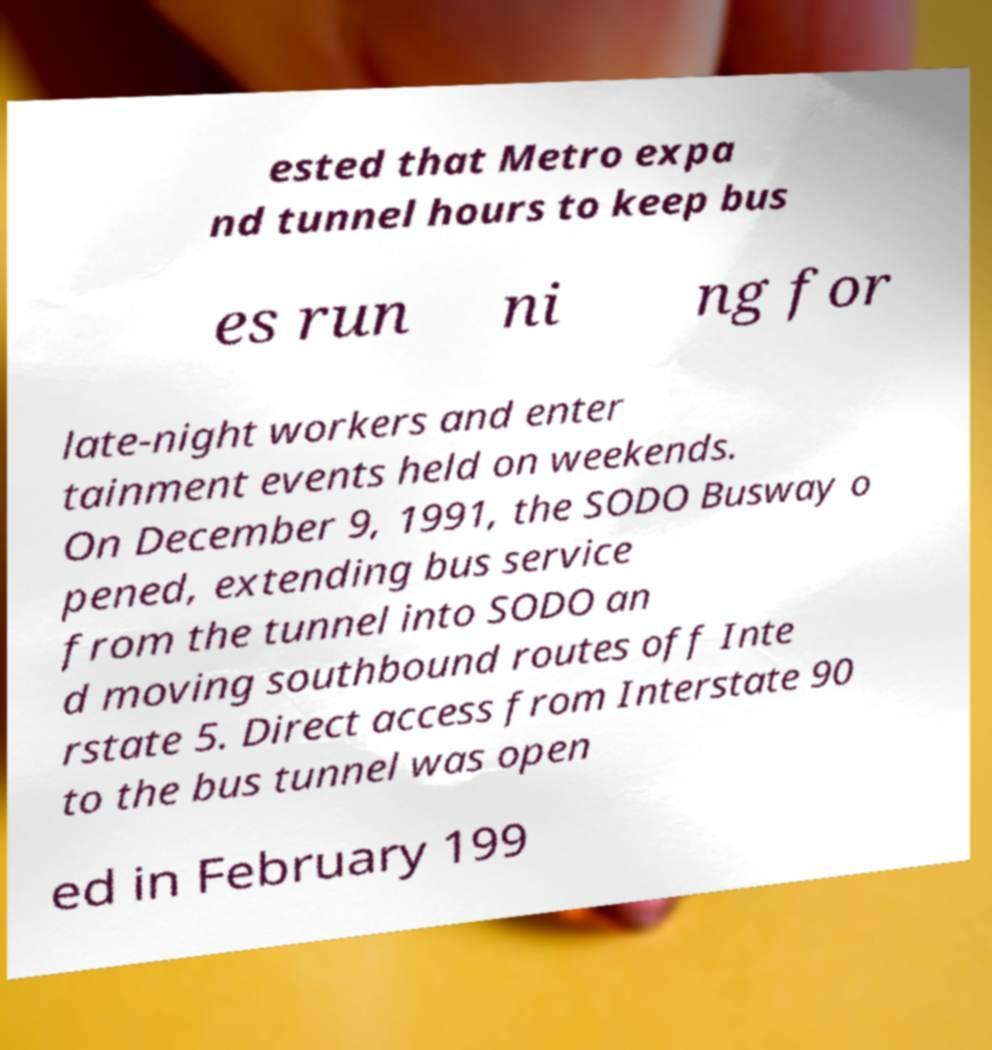For documentation purposes, I need the text within this image transcribed. Could you provide that? ested that Metro expa nd tunnel hours to keep bus es run ni ng for late-night workers and enter tainment events held on weekends. On December 9, 1991, the SODO Busway o pened, extending bus service from the tunnel into SODO an d moving southbound routes off Inte rstate 5. Direct access from Interstate 90 to the bus tunnel was open ed in February 199 